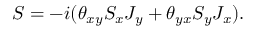Convert formula to latex. <formula><loc_0><loc_0><loc_500><loc_500>S = - i ( \theta _ { x y } S _ { x } J _ { y } + \theta _ { y x } S _ { y } J _ { x } ) .</formula> 